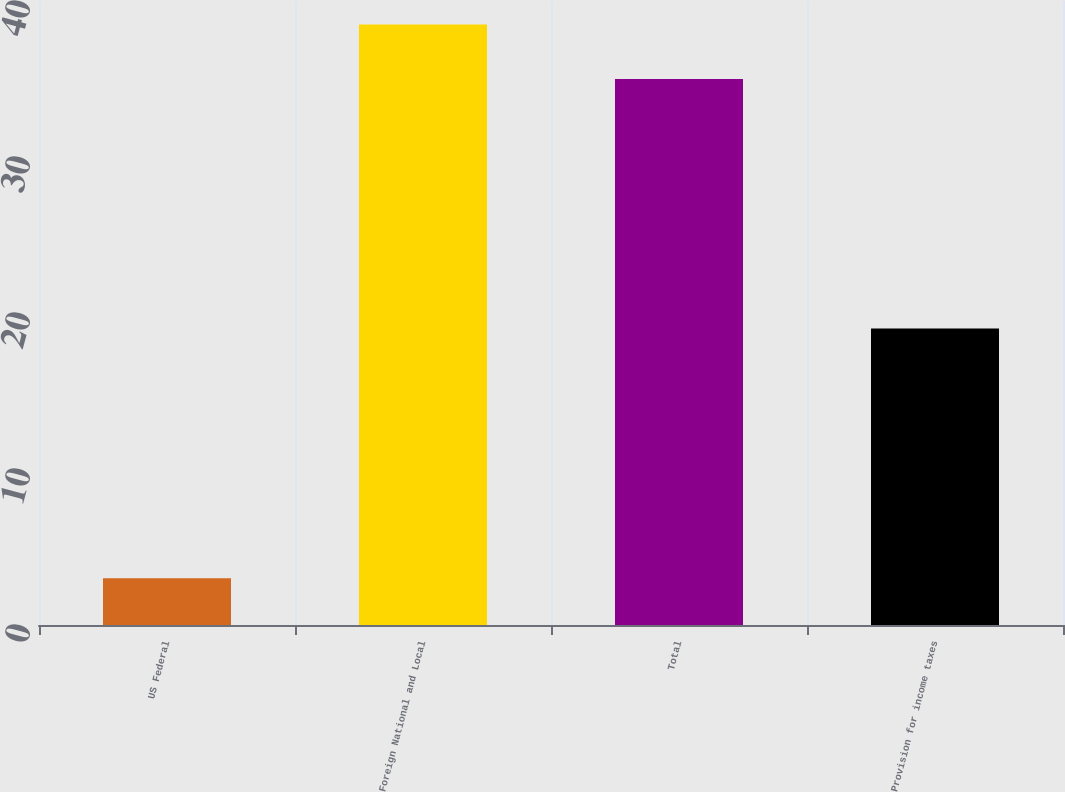Convert chart. <chart><loc_0><loc_0><loc_500><loc_500><bar_chart><fcel>US Federal<fcel>Foreign National and Local<fcel>Total<fcel>Provision for income taxes<nl><fcel>3<fcel>38.5<fcel>35<fcel>19<nl></chart> 